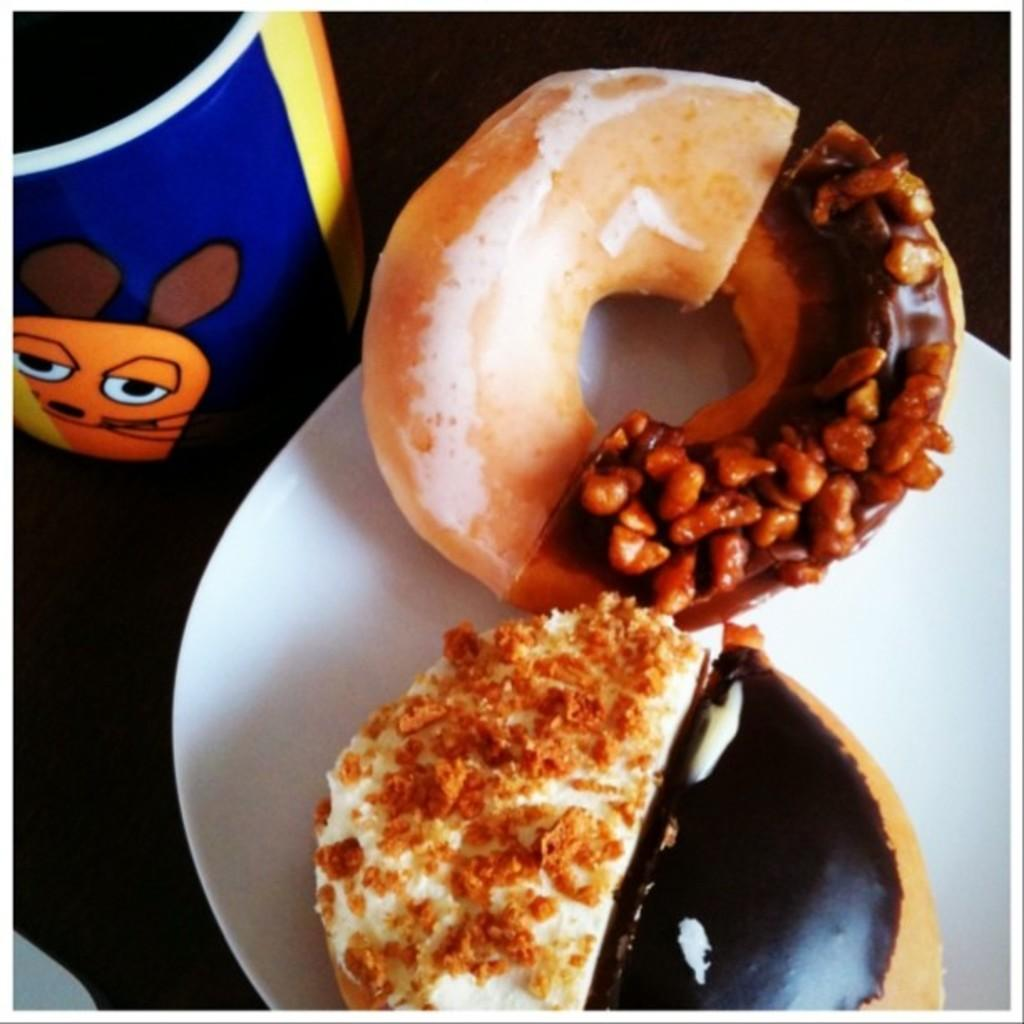What is the main food item on the plate in the image? There is a doughnut on a plate in the image. What other food item is present on the plate? There is a food item beside the doughnut on the plate. What can be seen on the table in the image? There is a glass on the table in the image. What type of lace can be seen on the doughnut in the image? There is no lace present on the doughnut in the image. How does the scale of the food items on the plate compare to the size of the glass on the table? The provided facts do not include information about the size or scale of the food items or the glass, so it is not possible to make a comparison. 